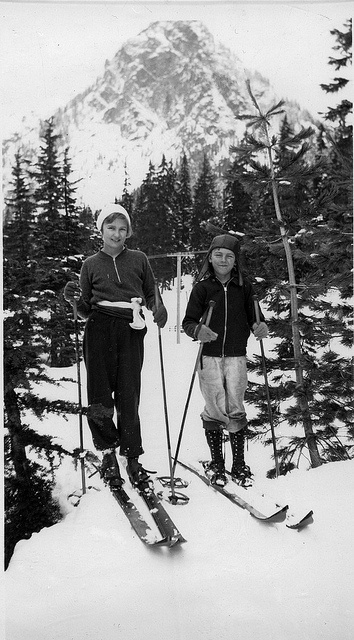Describe the objects in this image and their specific colors. I can see people in lightgray, black, gray, and darkgray tones, people in lightgray, black, gray, and darkgray tones, skis in lightgray, gray, black, and darkgray tones, and skis in lightgray, gray, darkgray, and black tones in this image. 